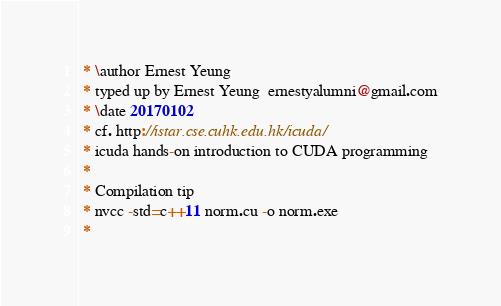<code> <loc_0><loc_0><loc_500><loc_500><_Cuda_> * \author Ernest Yeung
 * typed up by Ernest Yeung  ernestyalumni@gmail.com
 * \date 20170102
 * cf. http://istar.cse.cuhk.edu.hk/icuda/
 * icuda hands-on introduction to CUDA programming
 * 
 * Compilation tip
 * nvcc -std=c++11 norm.cu -o norm.exe
 * </code> 